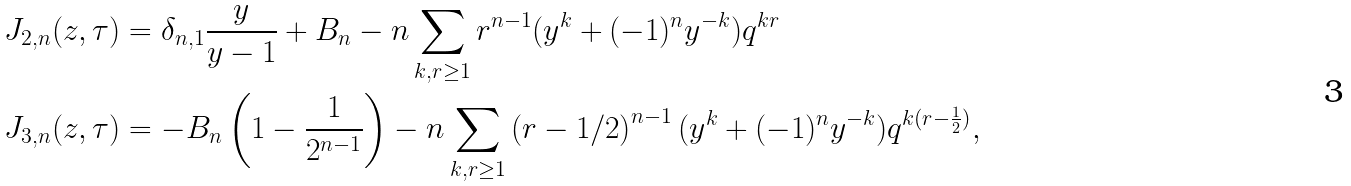<formula> <loc_0><loc_0><loc_500><loc_500>J _ { 2 , n } ( z , \tau ) & = \delta _ { n , 1 } \frac { y } { y - 1 } + B _ { n } - n \sum _ { k , r \geq 1 } r ^ { n - 1 } ( y ^ { k } + ( - 1 ) ^ { n } y ^ { - k } ) q ^ { k r } \\ J _ { 3 , n } ( z , \tau ) & = - B _ { n } \left ( 1 - \frac { 1 } { 2 ^ { n - 1 } } \right ) - n \sum _ { k , r \geq 1 } \left ( r - 1 / 2 \right ) ^ { n - 1 } ( y ^ { k } + ( - 1 ) ^ { n } y ^ { - k } ) q ^ { k ( r - \frac { 1 } { 2 } ) } ,</formula> 